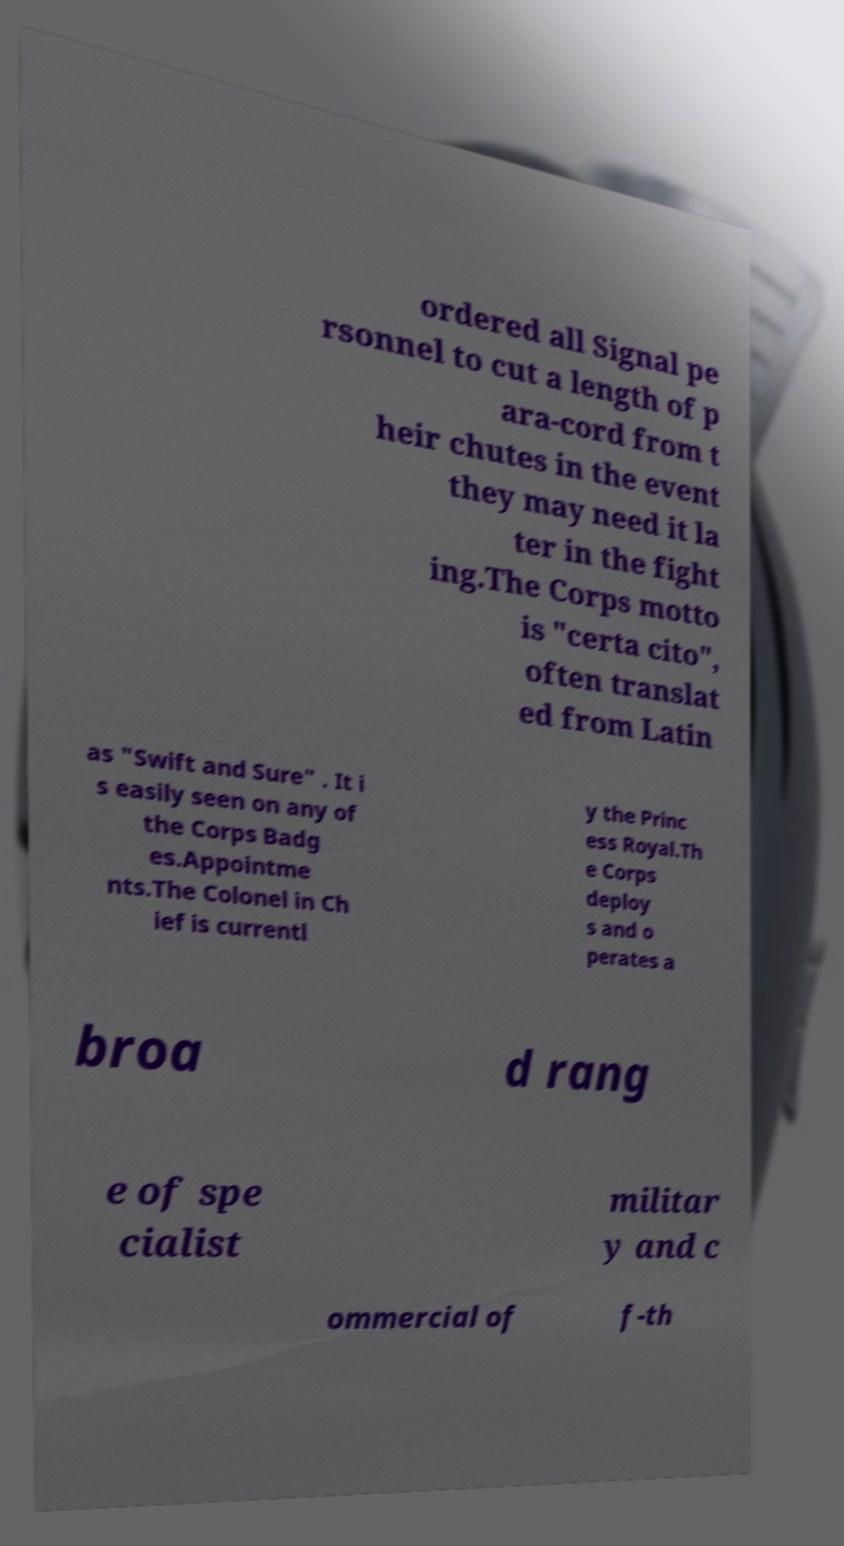What messages or text are displayed in this image? I need them in a readable, typed format. ordered all Signal pe rsonnel to cut a length of p ara-cord from t heir chutes in the event they may need it la ter in the fight ing.The Corps motto is "certa cito", often translat ed from Latin as "Swift and Sure" . It i s easily seen on any of the Corps Badg es.Appointme nts.The Colonel in Ch ief is currentl y the Princ ess Royal.Th e Corps deploy s and o perates a broa d rang e of spe cialist militar y and c ommercial of f-th 